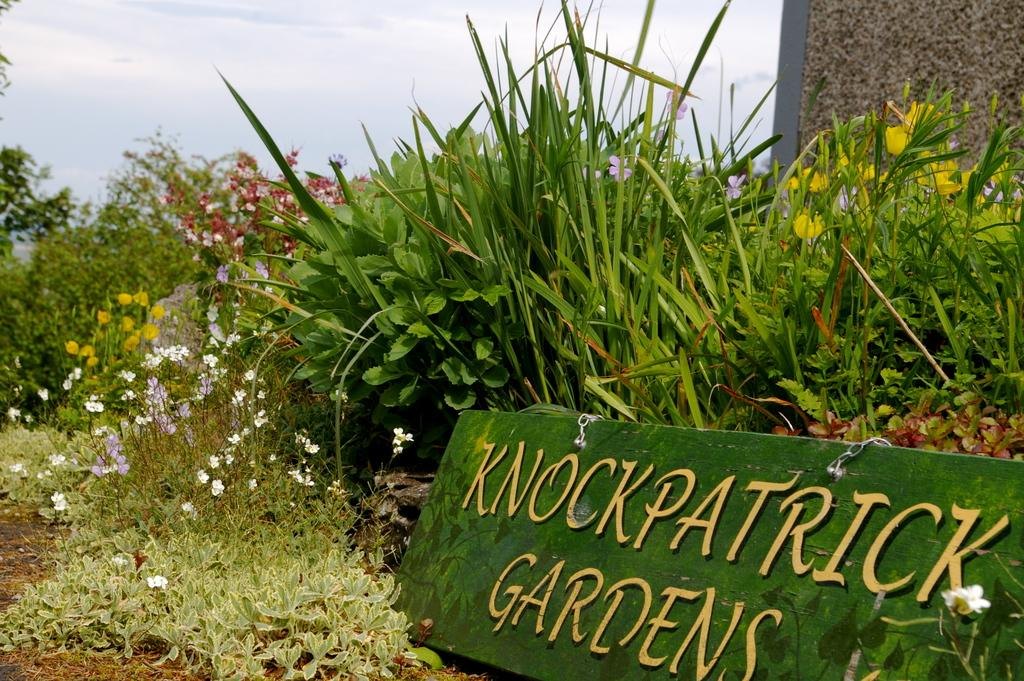What types of vegetation are present at the bottom of the image? There are plants and flowers at the bottom of the image. What can be seen in the sky at the top of the image? There are clouds in the sky at the top of the image. Can you see a cat walking along the railway in the image? There is no cat or railway present in the image. What type of home is visible in the image? There is no home present in the image; it features plants and flowers at the bottom and clouds in the sky at the top. 